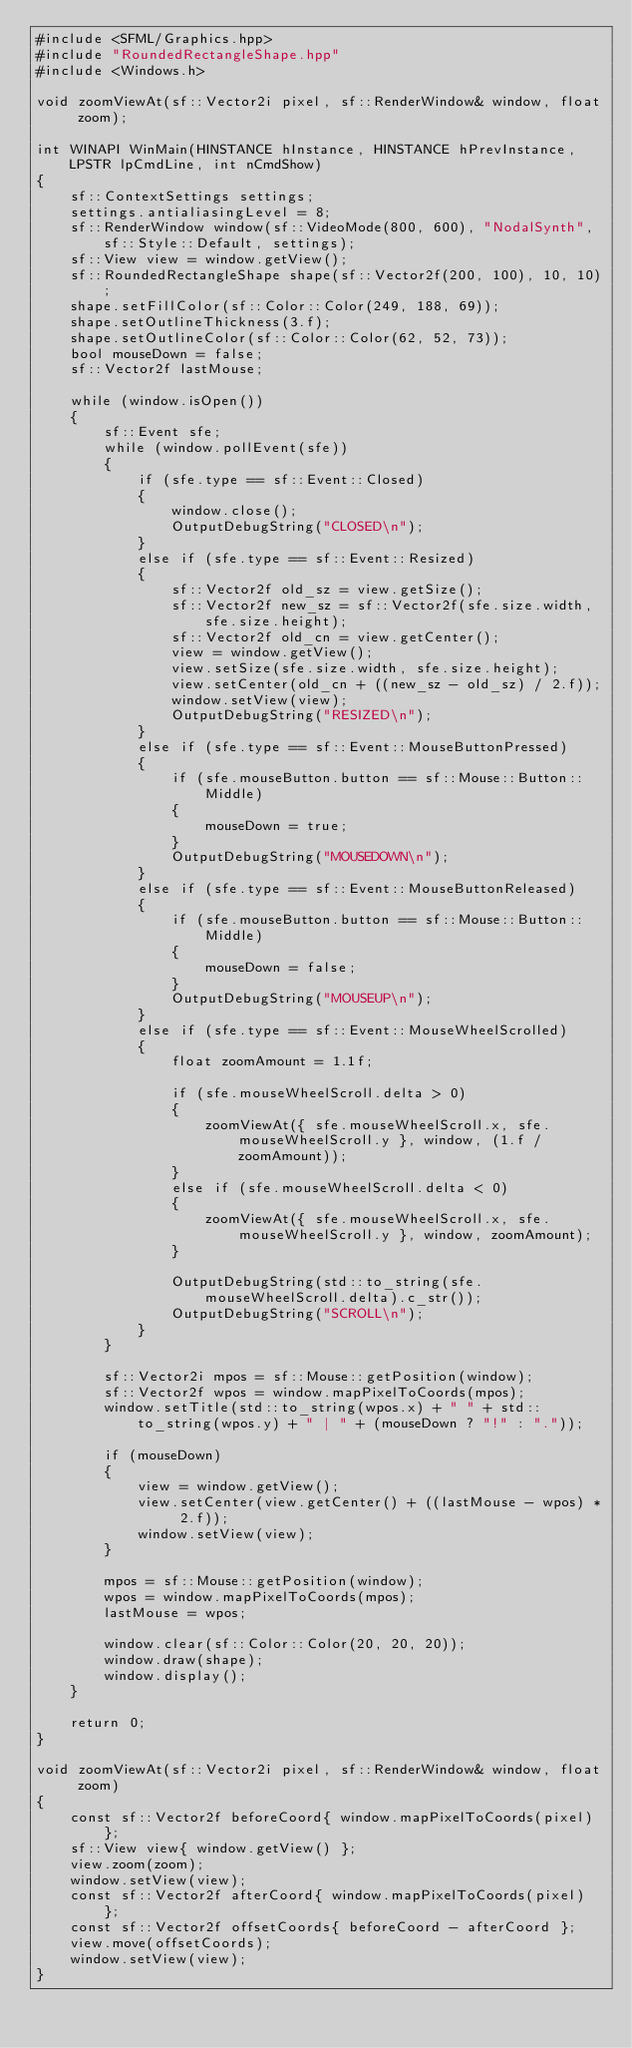<code> <loc_0><loc_0><loc_500><loc_500><_C++_>#include <SFML/Graphics.hpp>
#include "RoundedRectangleShape.hpp"
#include <Windows.h>

void zoomViewAt(sf::Vector2i pixel, sf::RenderWindow& window, float zoom);

int WINAPI WinMain(HINSTANCE hInstance, HINSTANCE hPrevInstance, LPSTR lpCmdLine, int nCmdShow)
{
	sf::ContextSettings settings;
	settings.antialiasingLevel = 8;
	sf::RenderWindow window(sf::VideoMode(800, 600), "NodalSynth", sf::Style::Default, settings);
	sf::View view = window.getView();
	sf::RoundedRectangleShape shape(sf::Vector2f(200, 100), 10, 10);
	shape.setFillColor(sf::Color::Color(249, 188, 69));
	shape.setOutlineThickness(3.f);
	shape.setOutlineColor(sf::Color::Color(62, 52, 73));
	bool mouseDown = false;
	sf::Vector2f lastMouse;

	while (window.isOpen())
	{
		sf::Event sfe;
		while (window.pollEvent(sfe))
		{
			if (sfe.type == sf::Event::Closed)
			{
				window.close();
				OutputDebugString("CLOSED\n");
			}
			else if (sfe.type == sf::Event::Resized)
			{
				sf::Vector2f old_sz = view.getSize();
				sf::Vector2f new_sz = sf::Vector2f(sfe.size.width, sfe.size.height);
				sf::Vector2f old_cn = view.getCenter();
				view = window.getView();
				view.setSize(sfe.size.width, sfe.size.height);
				view.setCenter(old_cn + ((new_sz - old_sz) / 2.f));
				window.setView(view);
				OutputDebugString("RESIZED\n");
			}
			else if (sfe.type == sf::Event::MouseButtonPressed)
			{
				if (sfe.mouseButton.button == sf::Mouse::Button::Middle)
				{
					mouseDown = true;
				}
				OutputDebugString("MOUSEDOWN\n");
			}
			else if (sfe.type == sf::Event::MouseButtonReleased)
			{
				if (sfe.mouseButton.button == sf::Mouse::Button::Middle)
				{
					mouseDown = false;
				}
				OutputDebugString("MOUSEUP\n");
			}
			else if (sfe.type == sf::Event::MouseWheelScrolled)
			{
				float zoomAmount = 1.1f;

				if (sfe.mouseWheelScroll.delta > 0)
				{
					zoomViewAt({ sfe.mouseWheelScroll.x, sfe.mouseWheelScroll.y }, window, (1.f / zoomAmount));
				}
				else if (sfe.mouseWheelScroll.delta < 0)
				{
					zoomViewAt({ sfe.mouseWheelScroll.x, sfe.mouseWheelScroll.y }, window, zoomAmount);
				}

				OutputDebugString(std::to_string(sfe.mouseWheelScroll.delta).c_str());
				OutputDebugString("SCROLL\n");
			}
		}

		sf::Vector2i mpos = sf::Mouse::getPosition(window);
		sf::Vector2f wpos = window.mapPixelToCoords(mpos);
		window.setTitle(std::to_string(wpos.x) + " " + std::to_string(wpos.y) + " | " + (mouseDown ? "!" : "."));

		if (mouseDown)
		{
			view = window.getView();
			view.setCenter(view.getCenter() + ((lastMouse - wpos) * 2.f));
			window.setView(view);
		}

		mpos = sf::Mouse::getPosition(window);
		wpos = window.mapPixelToCoords(mpos);
		lastMouse = wpos;

		window.clear(sf::Color::Color(20, 20, 20));
		window.draw(shape);
		window.display();
	}

	return 0;
}

void zoomViewAt(sf::Vector2i pixel, sf::RenderWindow& window, float zoom)
{
	const sf::Vector2f beforeCoord{ window.mapPixelToCoords(pixel) };
	sf::View view{ window.getView() };
	view.zoom(zoom);
	window.setView(view);
	const sf::Vector2f afterCoord{ window.mapPixelToCoords(pixel) };
	const sf::Vector2f offsetCoords{ beforeCoord - afterCoord };
	view.move(offsetCoords);
	window.setView(view);
}</code> 